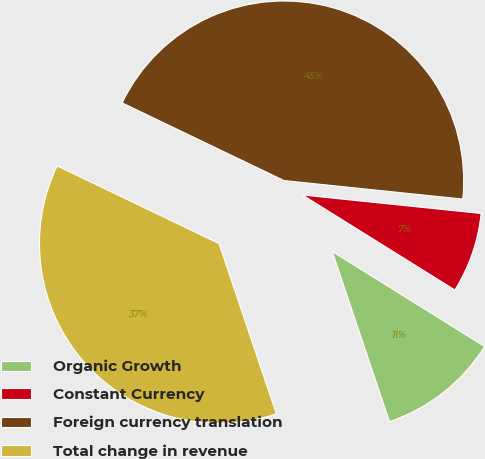Convert chart. <chart><loc_0><loc_0><loc_500><loc_500><pie_chart><fcel>Organic Growth<fcel>Constant Currency<fcel>Foreign currency translation<fcel>Total change in revenue<nl><fcel>10.96%<fcel>7.23%<fcel>44.52%<fcel>37.28%<nl></chart> 